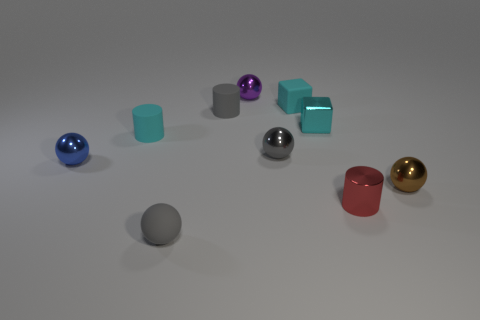Does the tiny gray cylinder in front of the purple metal thing have the same material as the brown object?
Give a very brief answer. No. Is there a small thing of the same color as the tiny matte block?
Offer a terse response. Yes. There is a purple object; what shape is it?
Give a very brief answer. Sphere. The small metal ball on the left side of the ball behind the gray metallic sphere is what color?
Provide a short and direct response. Blue. How big is the gray thing behind the gray shiny ball?
Your answer should be compact. Small. Is there a red object made of the same material as the brown object?
Offer a terse response. Yes. How many other small objects have the same shape as the red object?
Your answer should be compact. 2. The gray rubber thing that is behind the brown metal object that is to the right of the gray thing in front of the tiny brown ball is what shape?
Provide a succinct answer. Cylinder. The small sphere that is both behind the red cylinder and on the left side of the gray cylinder is made of what material?
Your answer should be compact. Metal. There is a cyan rubber thing right of the purple ball; is it the same size as the small red metallic thing?
Offer a terse response. Yes. 